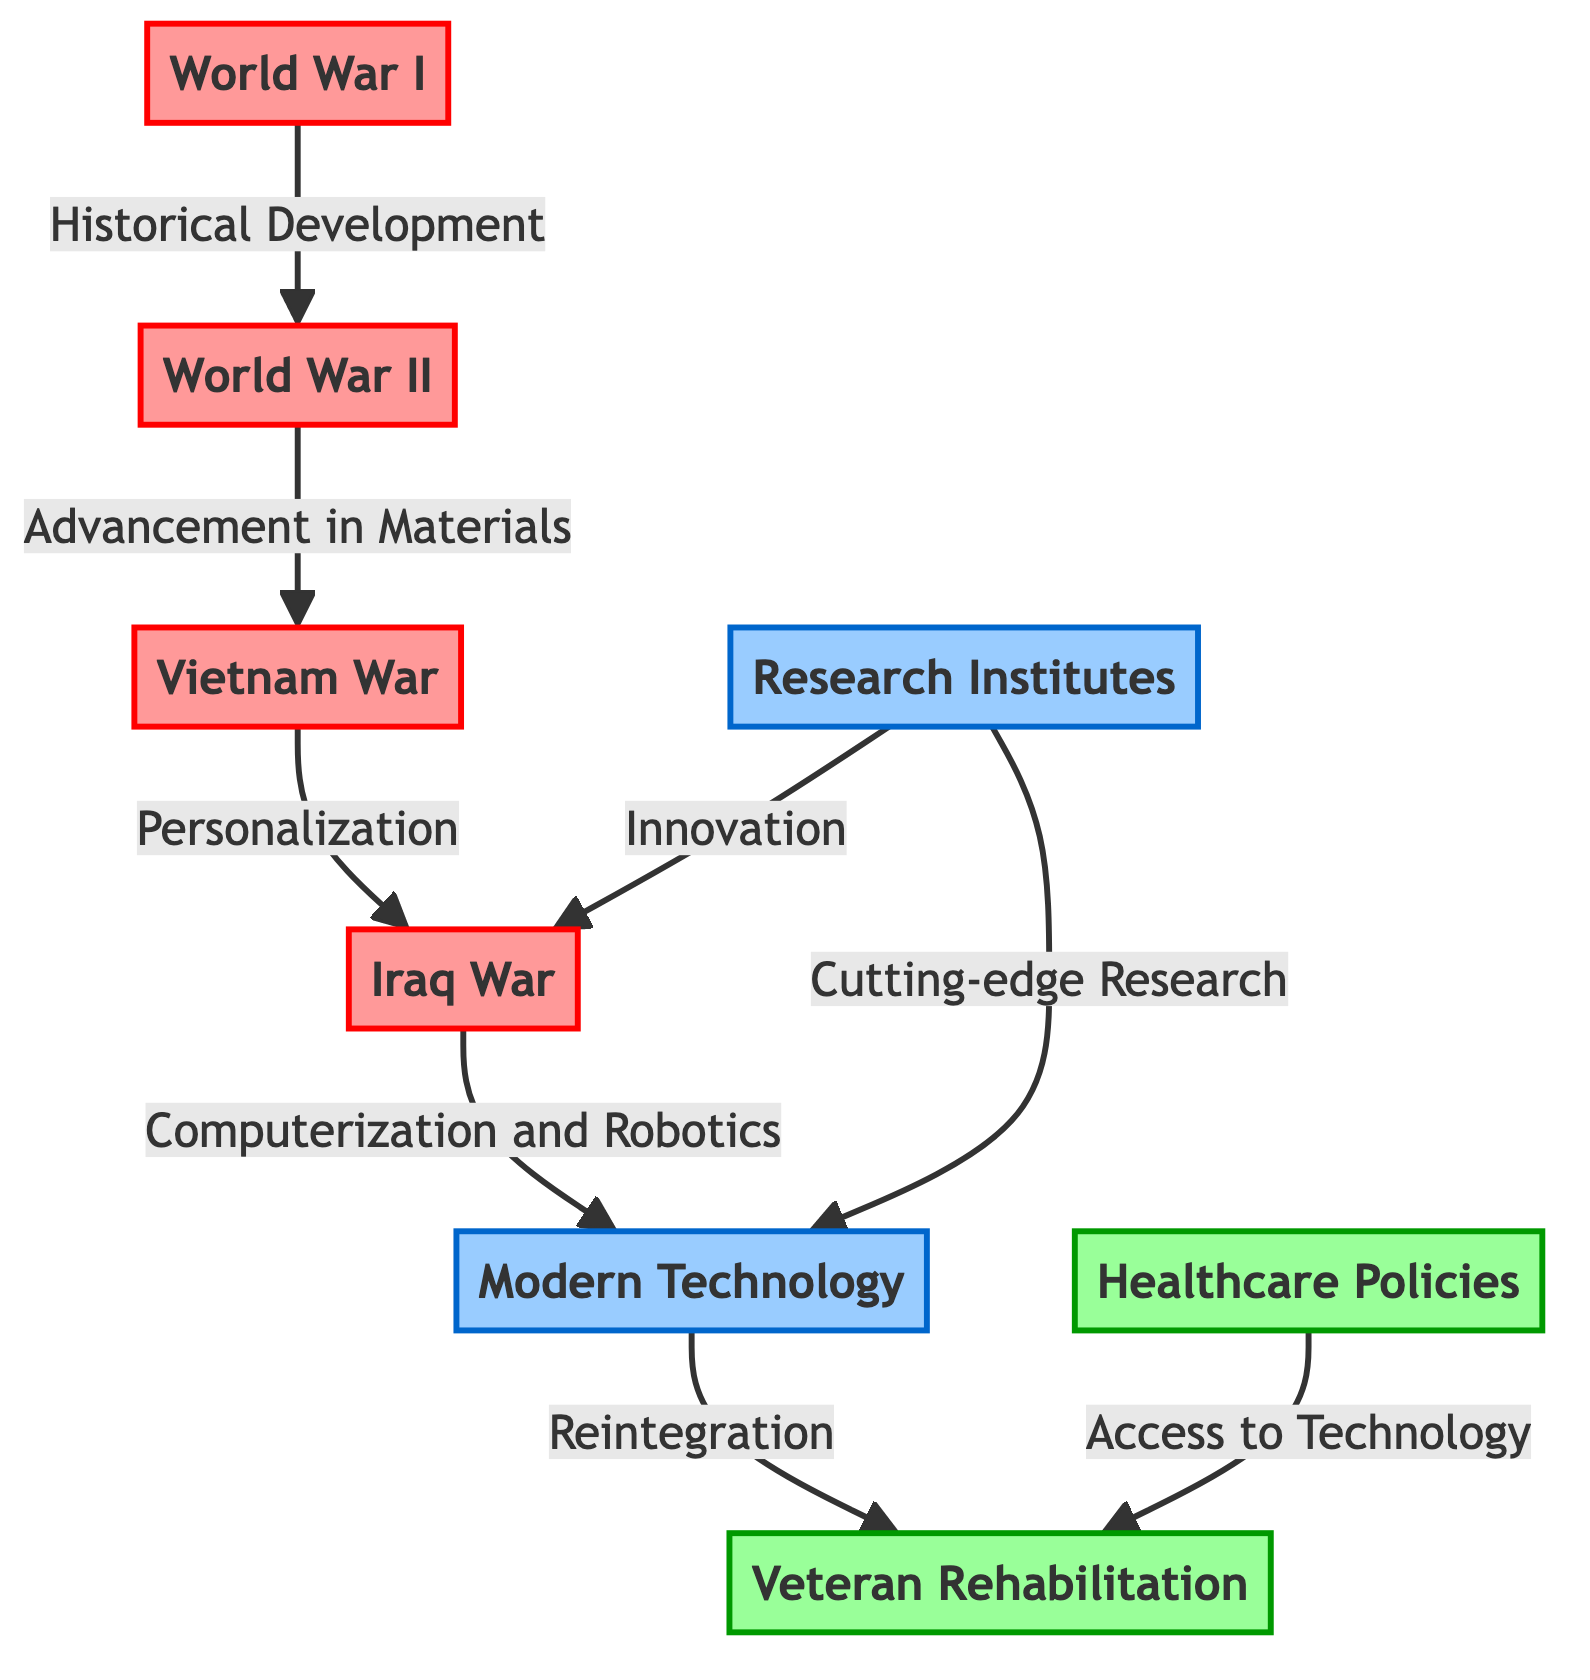What major war initiated the need for advanced prosthetics? The diagram identifies World War I as the event that initiated the need for more advanced, functional prosthetics due to the rise in limb amputations among soldiers.
Answer: World War I How many major wars are directly linked to advancements in prosthetic technology? The diagram shows four major wars (World War I, World War II, Vietnam War, Iraq War) that are linked to the evolution of prosthetic technology, indicated by the connections between nodes.
Answer: Four What technological advancement is associated with the Iraq War? The diagram states that advancements in computerized limbs and integration of robotics with prosthetic technology are associated with the Iraq War, as indicated by the directed edge leading to the "Modern Technology."
Answer: Computerization and Robotics Which two nodes are connected by the label "Access to Technology"? The connection labeled "Access to Technology" links the nodes representing Healthcare Policies and Veteran Rehabilitation as shown in the diagram.
Answer: Healthcare Policies and Veteran Rehabilitation What is the relationship represented between Modern Technology and Veteran Rehabilitation? The edge indicates that Modern Technology supports the process of Reintegration into society for veterans, suggesting a direct benefit of these advancements in prosthetics to their recovery and rehabilitation.
Answer: Reintegration How do Research Institutes contribute to advancements in prosthetic technology? The diagram shows that Research Institutes influence both the Iraq War and Modern Technology through their roles in innovation and cutting-edge research, as indicated by directed connections.
Answer: Innovation and Cutting-edge Research What is the primary focus of rehabilitation programs for veterans according to the diagram? The diagram highlights that Veteran Rehabilitation is aimed at the physical and mental recovery of veterans, emphasizing the importance of advanced prosthetics for their reintegration into civilian life.
Answer: Physical and Mental Recovery What advancement in materials occurred after World War I? Following World War I, the diagram illustrates a progression to World War II, which introduced significant advancements in materials and design, specifically mentioning lighter prosthetics made from aluminum and plastics.
Answer: Lighter Prosthetics Which node represents the evolution of healthcare policies for veterans? The node labeled "Healthcare Policies" signifies the evolution and enhancement of access to advanced prosthetic technology for veterans, as indicated by its connection to the Veteran Rehabilitation node.
Answer: Healthcare Policies 